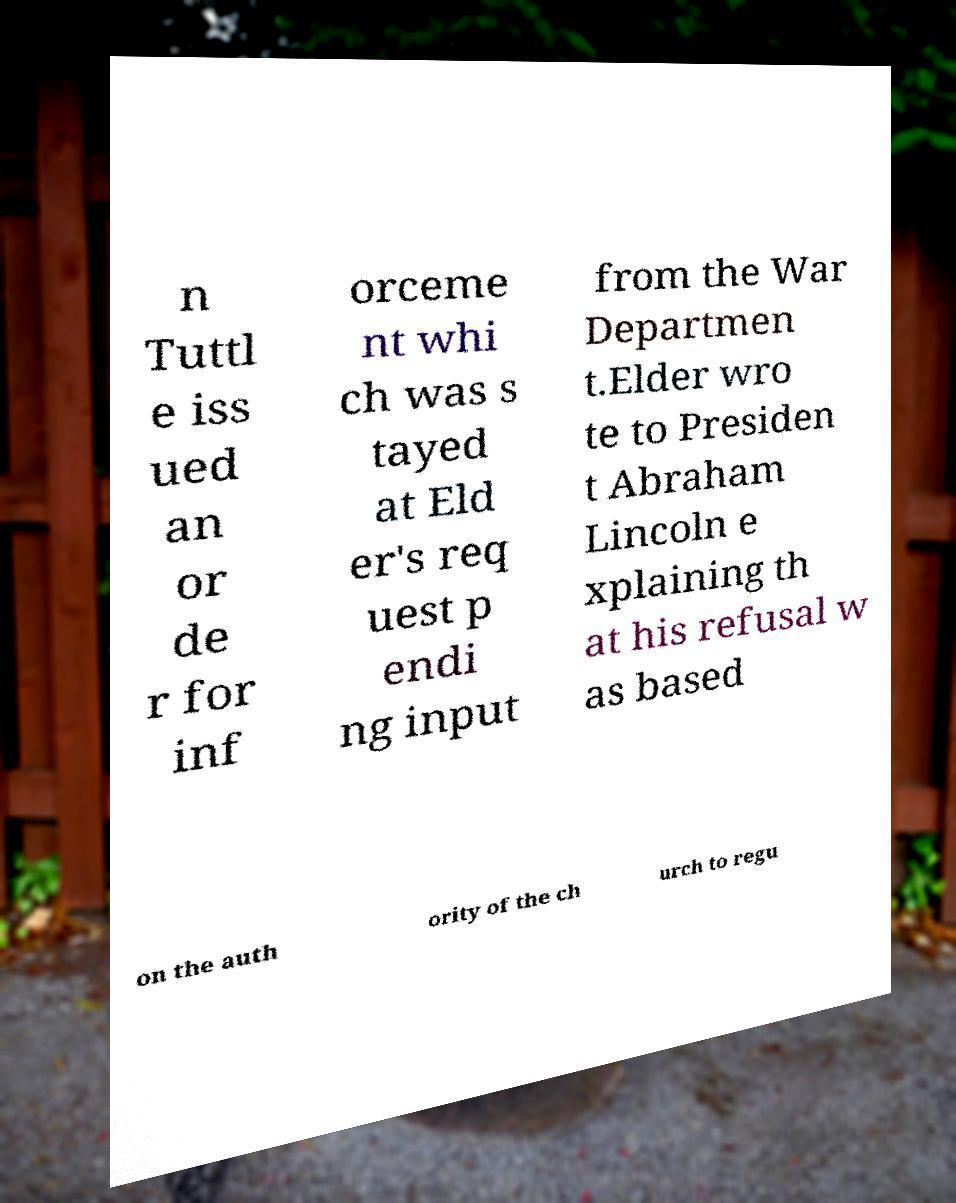For documentation purposes, I need the text within this image transcribed. Could you provide that? n Tuttl e iss ued an or de r for inf orceme nt whi ch was s tayed at Eld er's req uest p endi ng input from the War Departmen t.Elder wro te to Presiden t Abraham Lincoln e xplaining th at his refusal w as based on the auth ority of the ch urch to regu 